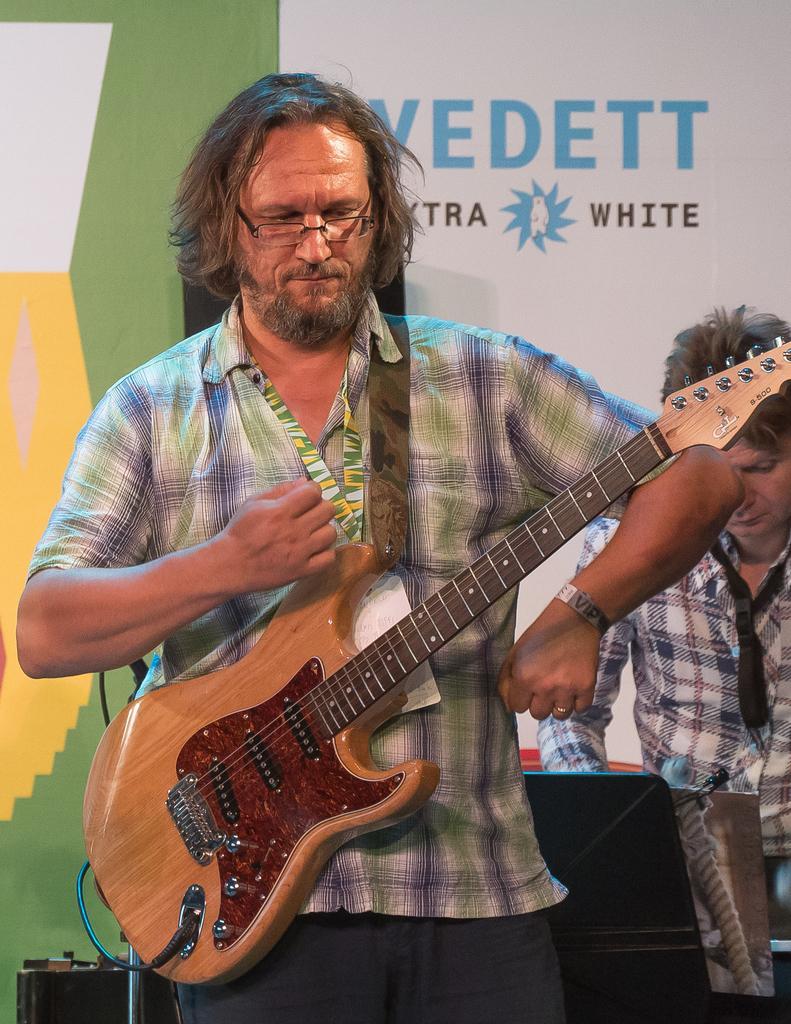In one or two sentences, can you explain what this image depicts? In this picture we can see a man standing and is wearing spectacles, he is looking on to the floor and is holding the guitar and in the backdrop there is other person standing and operating a laptop and in a backdrop there is a banner 